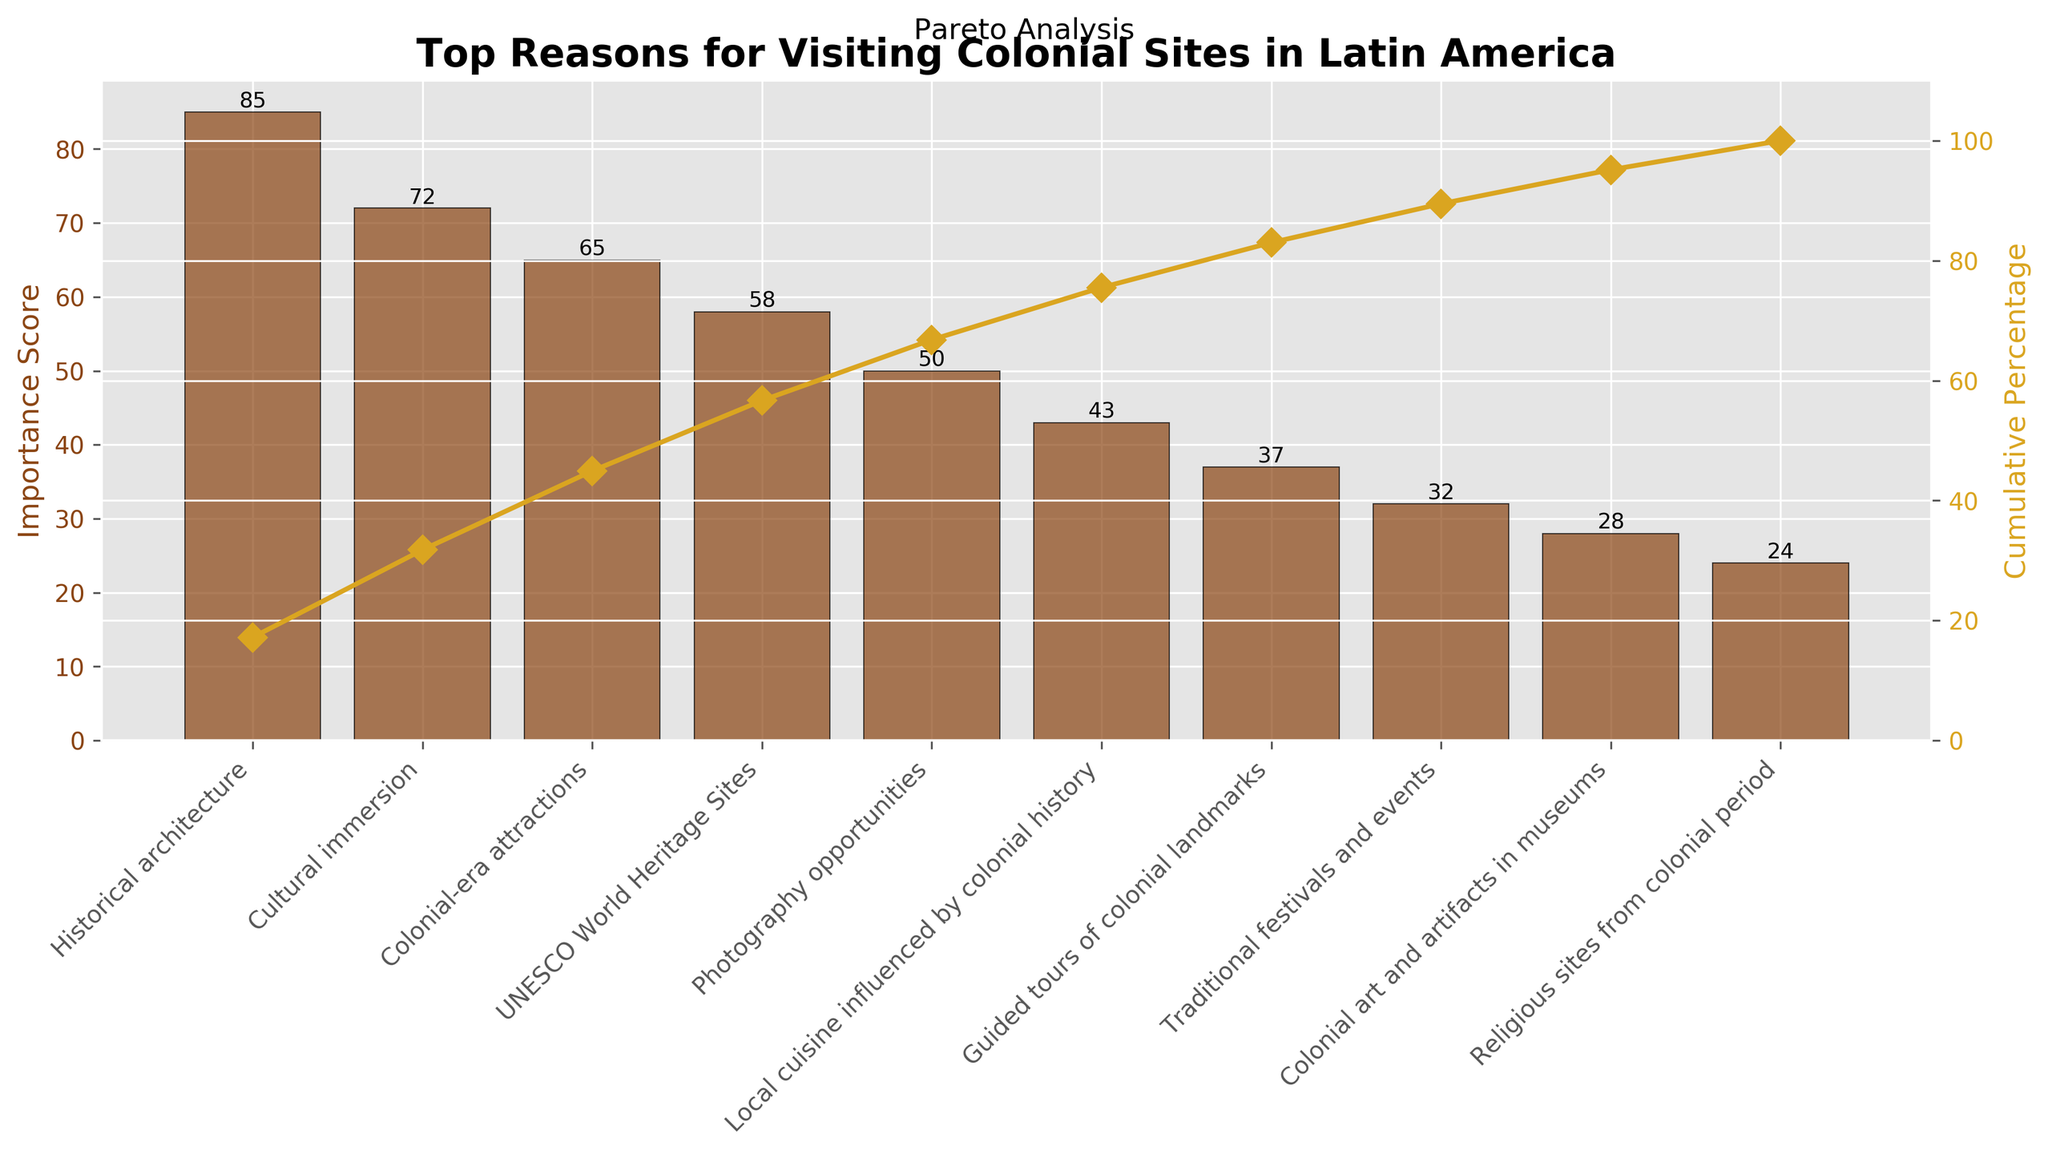What is the title of the chart? The title is displayed at the top of the chart and reads "Top Reasons for Visiting Colonial Sites in Latin America".
Answer: Top Reasons for Visiting Colonial Sites in Latin America What is the highest importance score on the chart? The highest importance score can be found by looking at the tallest bar, which represents Historical architecture with a score of 85.
Answer: 85 How many reasons are listed on the chart? The total number of bars on the chart indicates the number of reasons listed. By counting the bars, we see there are 10 reasons.
Answer: 10 Which reason has the lowest importance score? The lowest bar represents the reason with the lowest importance score. In this case, it is Religious sites from the colonial period with a score of 24.
Answer: Religious sites from the colonial period What is the cumulative percentage after the first three reasons? We add the cumulative percentages for the first three reasons: Historical architecture (85), Cultural immersion (72), and Colonial-era attractions (65). The cumulative percentage is calculated as (85+72+65)/total score.
Answer: 74.7% How many reasons have an importance score greater than 50? By examining the bars with scores above 50, we count Historical architecture, Cultural immersion, Colonial-era attractions, and UNESCO World Heritage Sites. There are 4 reasons in total.
Answer: 4 What is the difference in importance score between the top reason and the second top reason? We subtract the importance score of the second top reason (Cultural immersion, 72) from the top reason (Historical architecture, 85). The difference is 85 - 72.
Answer: 13 Which reason has an importance score closest to the median score? To find the median, we list out the scores in order: 24, 28, 32, 37, 43, 50, 58, 65, 72, 85. The median is the average of the 5th and 6th scores: (43+50)/2 = 46.5. The reason with a score closest to this is Local cuisine influenced by colonial history with a score of 43.
Answer: Local cuisine influenced by colonial history What percentage of the total importance score is represented by the top three reasons? We calculate the sum of the importance scores for the top three reasons: 85 (Historical architecture) + 72 (Cultural immersion) + 65 (Colonial-era attractions). The total importance score is 494. The percentage is (85+72+65)/494*100%.
Answer: ~45.95% What is indicated by the line graph in the Pareto chart? The line graph represents the cumulative percentage of importance scores, showing how the total importance accumulates as each reason is added.
Answer: Cumulative percentage 